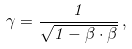Convert formula to latex. <formula><loc_0><loc_0><loc_500><loc_500>\gamma = { \frac { 1 } { \sqrt { 1 - { \beta } \cdot { \beta } } } } \, ,</formula> 